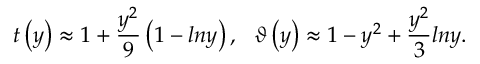Convert formula to latex. <formula><loc_0><loc_0><loc_500><loc_500>{ t } \left ( y \right ) \approx 1 + \frac { y ^ { 2 } } { 9 } \left ( 1 - \ln y \right ) , \vartheta \left ( y \right ) \approx 1 - y ^ { 2 } + \frac { y ^ { 2 } } { 3 } \ln y .</formula> 